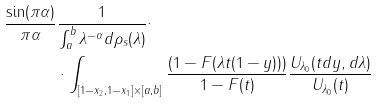Convert formula to latex. <formula><loc_0><loc_0><loc_500><loc_500>\frac { \sin ( \pi \alpha ) } { \pi \alpha } & \frac { 1 } { \int _ { a } ^ { b } \lambda ^ { - \alpha } d \rho _ { s } ( \lambda ) } \cdot \\ & \cdot \int _ { [ 1 - x _ { 2 } , 1 - x _ { 1 } ] \times [ a , b ] } \frac { ( 1 - F ( \lambda t ( 1 - y ) ) ) } { 1 - F ( t ) } \frac { U _ { \lambda _ { 0 } } ( t d y , d \lambda ) } { U _ { \lambda _ { 0 } } ( t ) }</formula> 